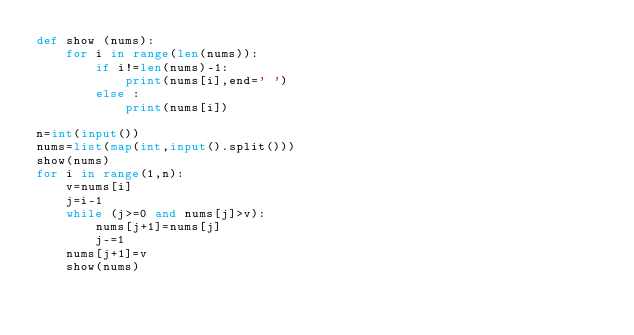<code> <loc_0><loc_0><loc_500><loc_500><_Python_>def show (nums):
    for i in range(len(nums)):
        if i!=len(nums)-1:
            print(nums[i],end=' ')
        else :
            print(nums[i])
 
n=int(input())
nums=list(map(int,input().split()))
show(nums)
for i in range(1,n):
    v=nums[i]
    j=i-1
    while (j>=0 and nums[j]>v):
        nums[j+1]=nums[j]
        j-=1
    nums[j+1]=v
    show(nums)
 
    
</code> 